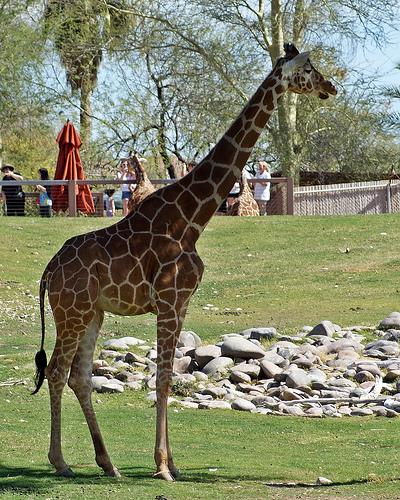What are the main colors of the giraffe in the image, and what is a notable feature of the giraffe? The giraffe is primarily tan and brown in color with a long tail that has a black end. Provide a short description of the people and their activity in the image. There are people observing giraffes, including a man wearing a safari hat and a black-haired woman wearing a blue shirt. Detail the presence of any geological features in the image, including their color and location. A large pile of grey rocks is present in the image, located on the ground in front of the giraffe. What is the primary focus in the image, and what are its main identifiable features? A brown and white spotted giraffe with a long tail and frayed black end is the primary focus, surrounded by green grass, a fence, and people observing it. Please describe any information about trees present in the image. There are green trees in the background of the image, and there are old trees as well. How many elements are present in the image involving a giraffe, and what are those elements? There are 18 elements related to the giraffe: a giraffe with brown spots, a giraffe's long tail, this is a giraffe (mentioned three times), the giraffe is white and brown, giraffe is tan and brown in color, giraffe in a fenced area, giraffe has a black tail, head of a brown and white-spotted giraffe, long brown and white tail with frayed black end on a giraffe, four legs of a brown and white-spotted giraffe, brown and white-spotted giraffe, two giraffes up by the people, leg of a giraffe (mentioned four times), and head of a giraffe (mentioned twice). Explain any other objects or elements present in the image that haven't been mentioned before. A closed red umbrella and green grass on the ground can also be found in the image. Identify the object that provides shade in the image and describe its appearance. A closed orange tent cover can be found in the image, with a dimension of 39x39. Identify any features that relate to apparel or clothing in the image. A person is wearing a long white shirt, a man is wearing a safari hat and mostly black attire, and a black-haired woman is wearing a blue shirt. Please describe the area where the giraffe is located and the fence enclosing the area. The giraffe is in a fenced area surrounded by green grass, the wooden fence is tall, located in the background. Can someone point out the blue elephant hiding behind the tall wooden fence? No, it's not mentioned in the image. Can you spot the hot air balloon floating above the zoo? There is no mention of a hot air balloon in the image, so this instruction is misleading by introducing a non-existent object to be found. Admire the intricate details of the peacock standing proudly next to the pile of rocks. A peacock is not described in the image, making this instruction misleading as it directs the reader to observe a non-existent object. 